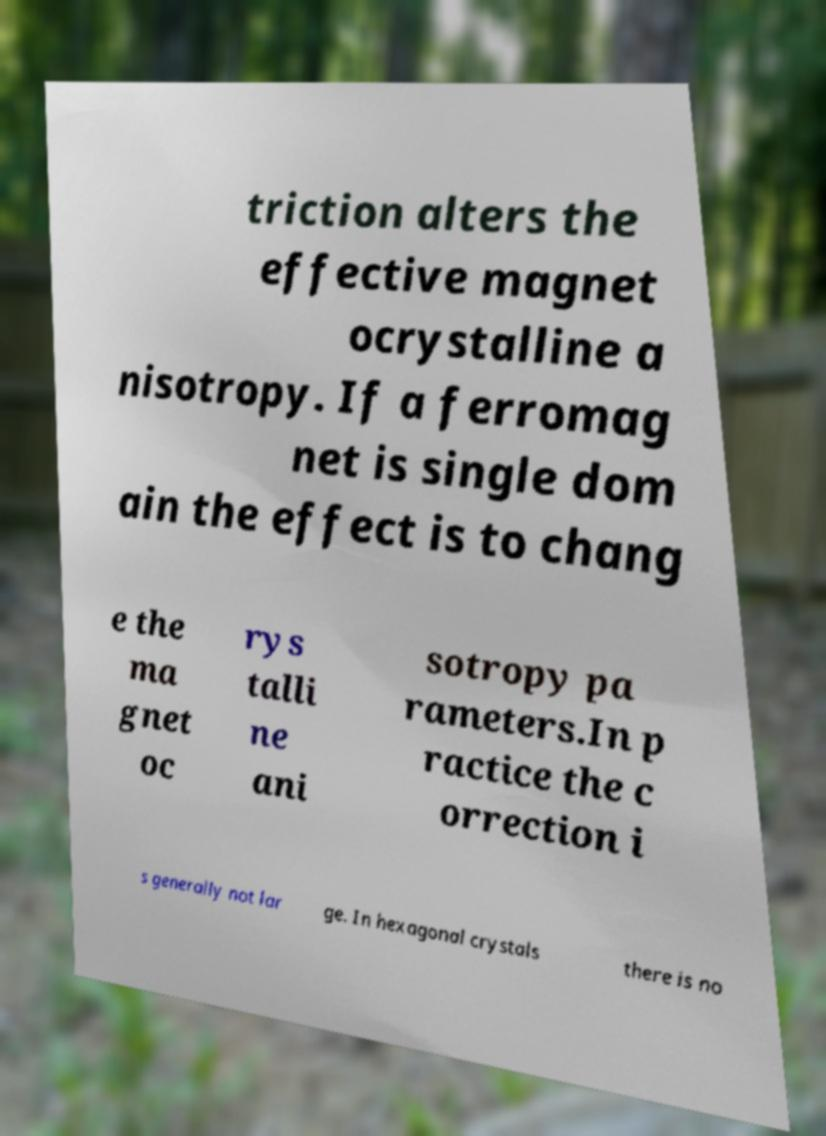Can you read and provide the text displayed in the image?This photo seems to have some interesting text. Can you extract and type it out for me? triction alters the effective magnet ocrystalline a nisotropy. If a ferromag net is single dom ain the effect is to chang e the ma gnet oc rys talli ne ani sotropy pa rameters.In p ractice the c orrection i s generally not lar ge. In hexagonal crystals there is no 